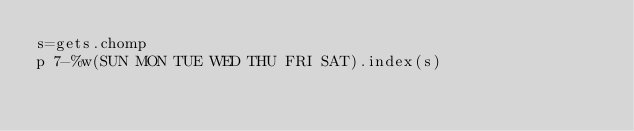<code> <loc_0><loc_0><loc_500><loc_500><_Ruby_>s=gets.chomp
p 7-%w(SUN MON TUE WED THU FRI SAT).index(s)</code> 